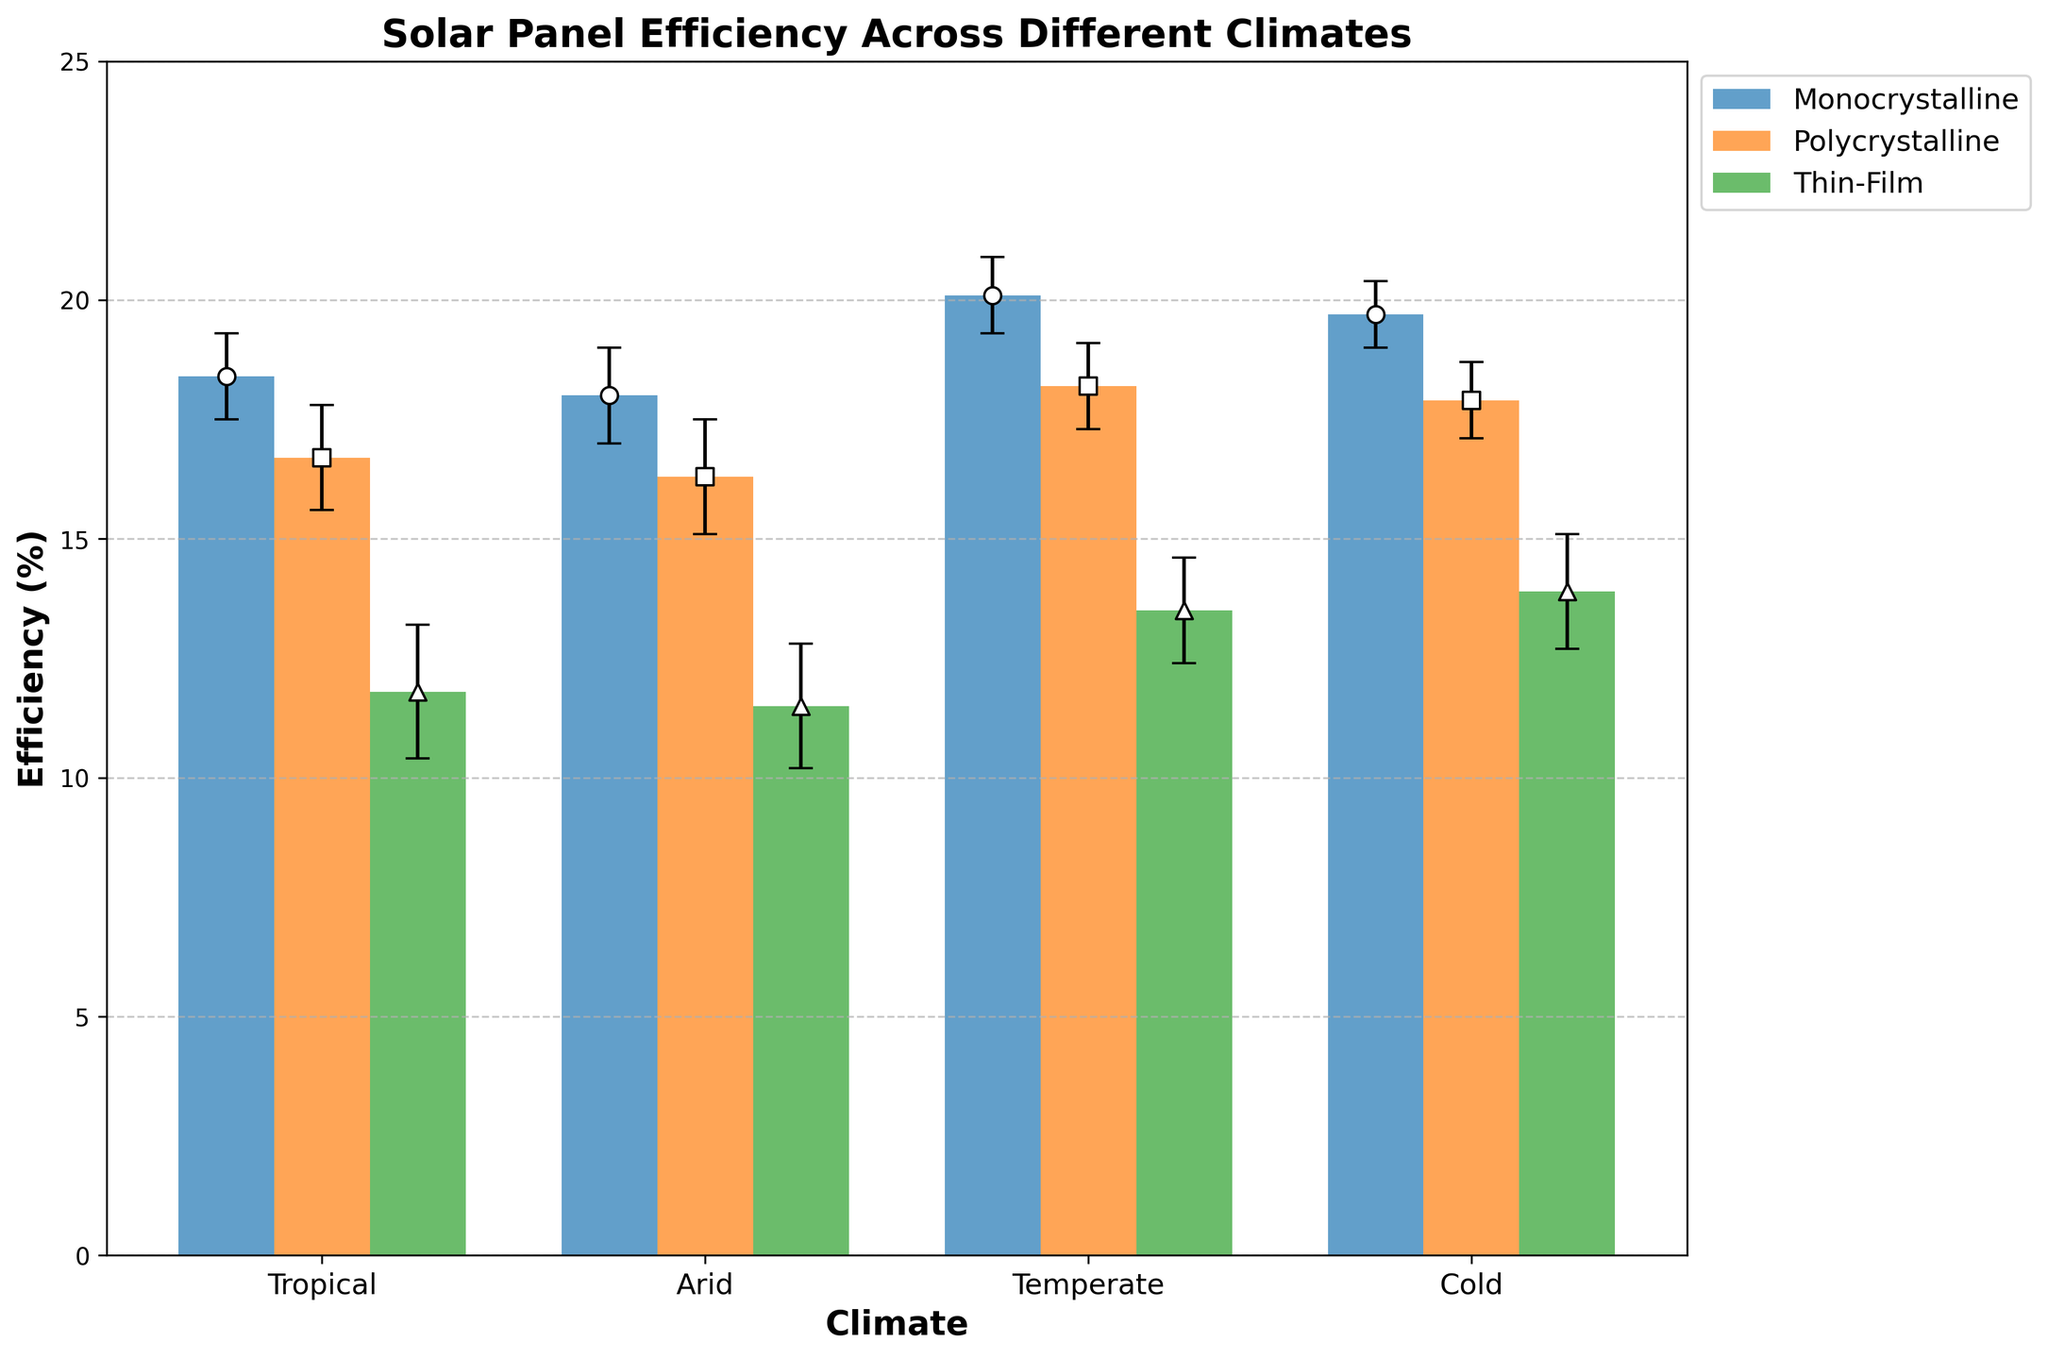What is the title of the figure? The title of the figure is typically located at the top of the plot. In this case, it is clearly stated.
Answer: Solar Panel Efficiency Across Different Climates What is the maximum efficiency observed in the Temperate climate? From the Temperate climate bar groups, the maximum efficiency can be found by locating the tallest bar in this group and noting its value. The tallest bar represents Monocrystalline panels.
Answer: 20.1% Which solar panel type generally performs best across all climates? To determine the best performer, look at the mean efficiency values for each panel type across all climates. Monocrystalline panels have consistently higher mean efficiencies.
Answer: Monocrystalline What is the efficiency difference between Monocrystalline and Thin-Film panels in Tropical climates? Find the respective efficiency values for Monocrystalline and Thin-Film panels in the Tropical climate and calculate the difference: 18.4 - 11.8.
Answer: 6.6% What is the average efficiency of Polycrystalline panels across all climates? Calculate the average by summing the mean efficiency values of Polycrystalline panels in all climates and dividing by the number of climates: (16.7 + 16.3 + 18.2 + 17.9) / 4.
Answer: 17.275% Which climate has the highest average efficiency for all panel types combined? Calculate the combined average efficiency for each climate and compare: 
- Tropical: (18.4 + 16.7 + 11.8) / 3 = 15.63
- Arid: (18.0 + 16.3 + 11.5) / 3 = 15.27
- Temperate: (20.1 + 18.2 + 13.5) / 3 = 17.27
- Cold: (19.7 + 17.9 + 13.9) / 3 = 17.17
The highest average is in the Temperate climate.
Answer: Temperate What is the standard deviation of Thin-Film panels in the Arid climate? The standard deviation specific to Thin-Film panels in the Arid climate is provided in the data.
Answer: 1.3 Which panel type shows the least variation in efficiency across different climates? Assess the standard deviations for each panel type across all climates:
- Monocrystalline: (0.9 + 1.0 + 0.8 + 0.7)
- Polycrystalline: (1.1 + 1.2 + 0.9 + 0.8)
- Thin-Film: (1.4 + 1.3 + 1.1 + 1.2)
Thin-Film panels show higher variations than others. Monocrystalline panels have the smallest deviations.
Answer: Monocrystalline In which climate does Thin-Film panel outperform the other panel types the most? Check the efficiency of Thin-Film panels against Monocrystalline and Polycrystalline in each climate and find where the gap is the largest:
- Tropical: significantly lower than others.
- Arid: significantly lower than others.
- Temperate: significantly lower than others.
- Cold: significantly lower than others.
It underperforms most in all climates. There is no climate where it outperforms.
Answer: None 